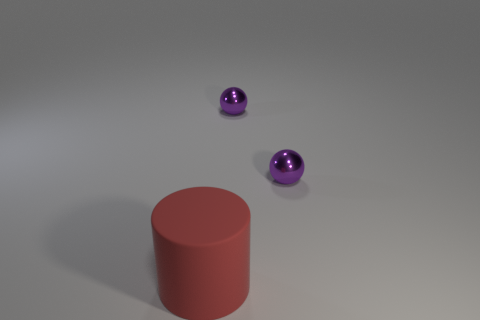Add 3 red cylinders. How many objects exist? 6 Subtract all cylinders. How many objects are left? 2 Subtract all large cylinders. Subtract all balls. How many objects are left? 0 Add 3 purple spheres. How many purple spheres are left? 5 Add 1 big red matte cylinders. How many big red matte cylinders exist? 2 Subtract 0 purple cylinders. How many objects are left? 3 